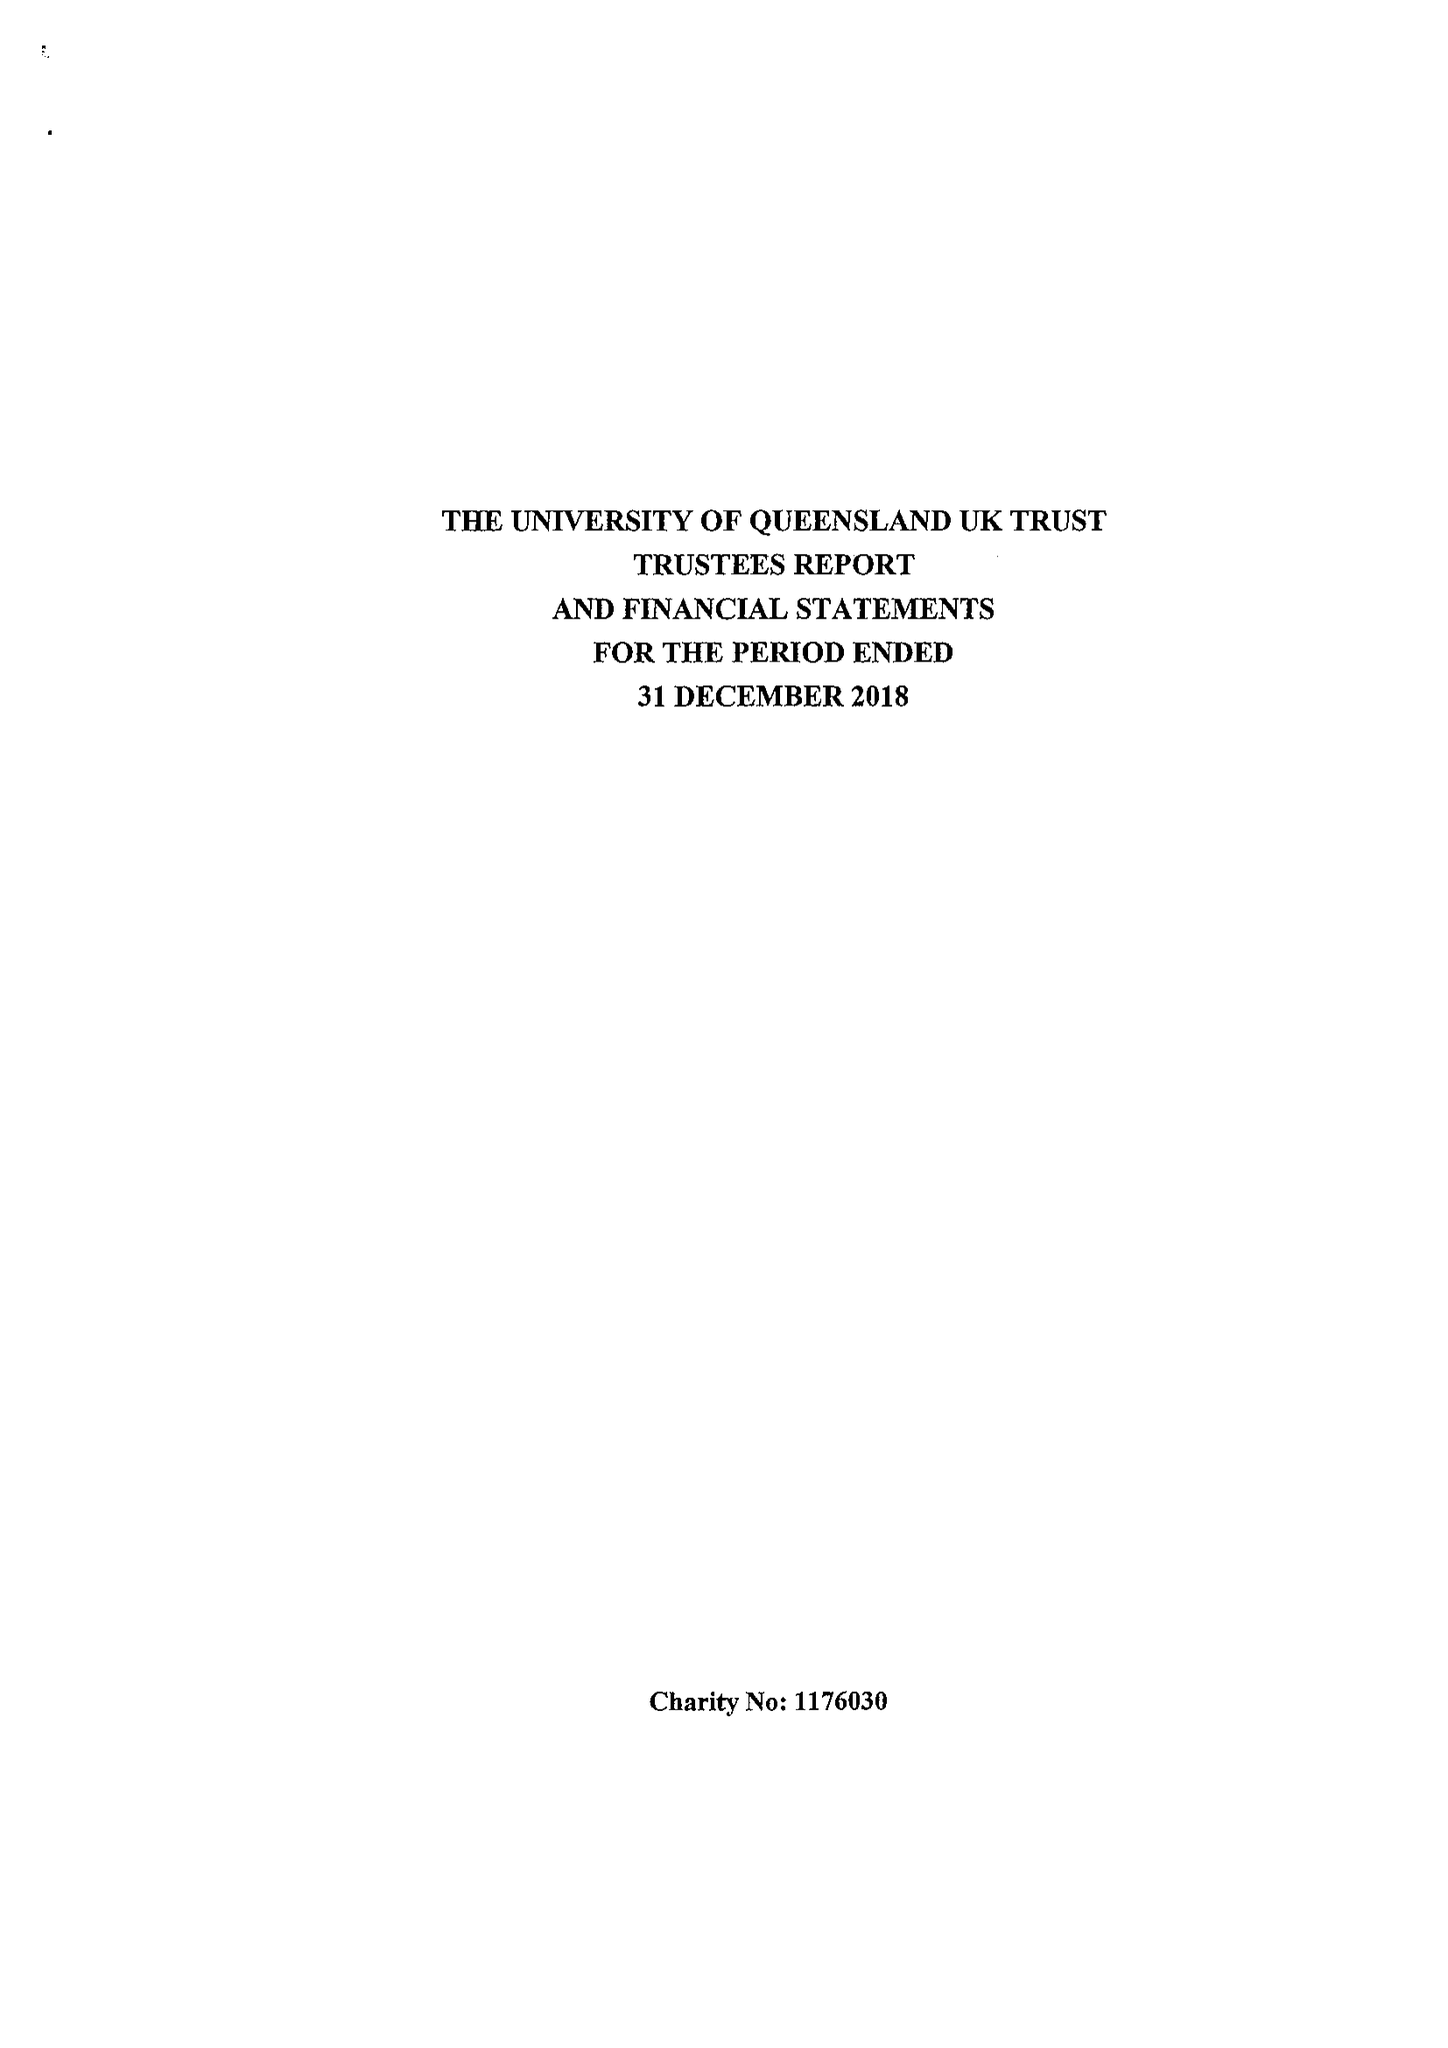What is the value for the income_annually_in_british_pounds?
Answer the question using a single word or phrase. 9039.00 